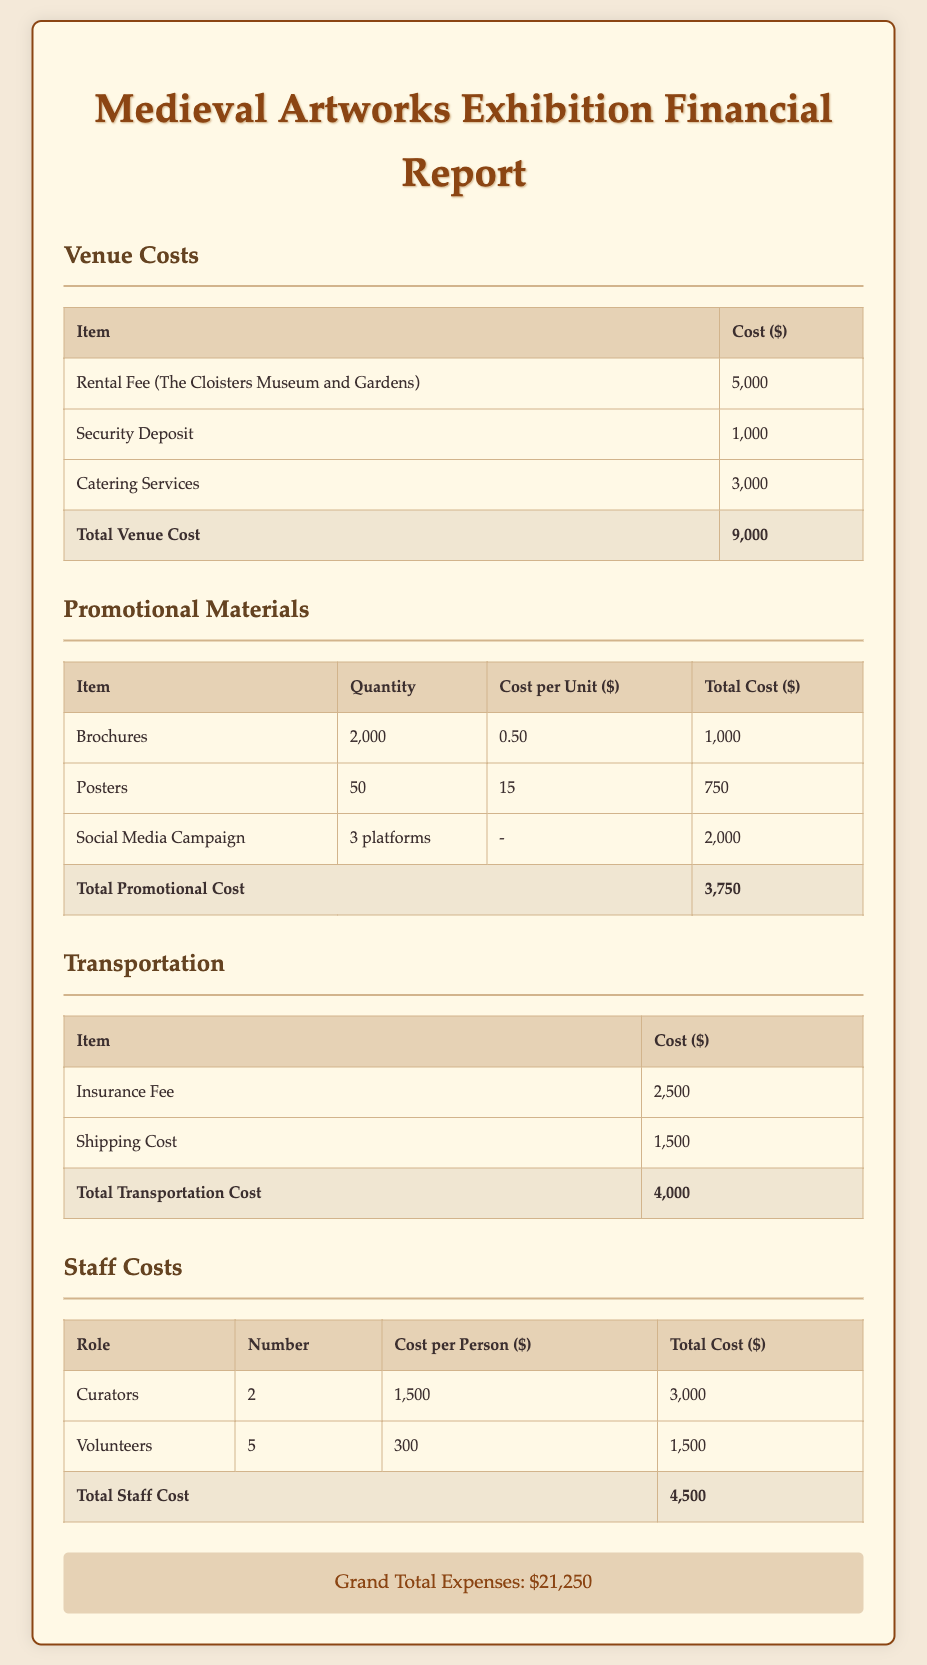what is the total venue cost? The total venue cost is located at the bottom of the venue costs table, summing up all venue-related expenses.
Answer: 9,000 how many brochures were printed? The number of brochures printed is stated in the promotional materials table under the quantity for brochures.
Answer: 2,000 what was the cost for catering services? The cost for catering services is found in the venue costs section, detailing the specific expense.
Answer: 3,000 what is the grand total of all expenses? The grand total is provided at the end of the report, indicating the cumulative expenses incurred.
Answer: 21,250 how much was spent on social media campaigns? The total cost for social media campaigns is indicated in the promotional materials section of the document.
Answer: 2,000 how many curators were employed for the exhibition? The number of curators is directly stated in the staff costs table, detailing staff roles and counts.
Answer: 2 what is the total cost for staff? The total cost for staff is the summed expense from the staff costs section, encompassing all roles and their associated expenses.
Answer: 4,500 what was the shipping cost for transportation? The shipping cost is specifically mentioned in the transportation table under the respective item.
Answer: 1,500 what is the cost per unit for posters? The cost per unit for posters is detailed in the promotional materials table next to the corresponding item entry.
Answer: 15 